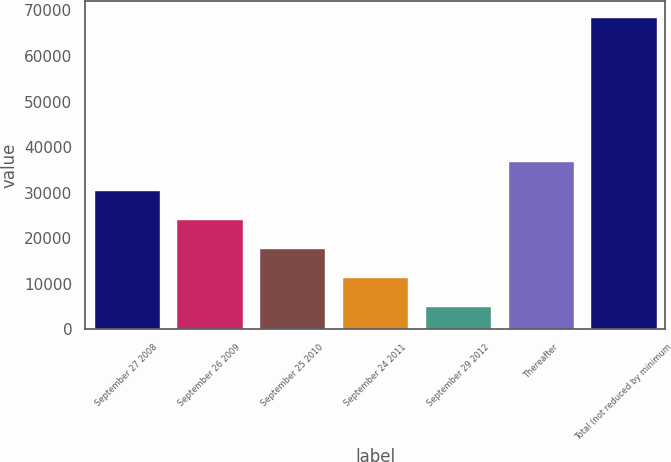<chart> <loc_0><loc_0><loc_500><loc_500><bar_chart><fcel>September 27 2008<fcel>September 26 2009<fcel>September 25 2010<fcel>September 24 2011<fcel>September 29 2012<fcel>Thereafter<fcel>Total (not reduced by minimum<nl><fcel>30581.2<fcel>24242.9<fcel>17904.6<fcel>11566.3<fcel>5228<fcel>36919.5<fcel>68611<nl></chart> 